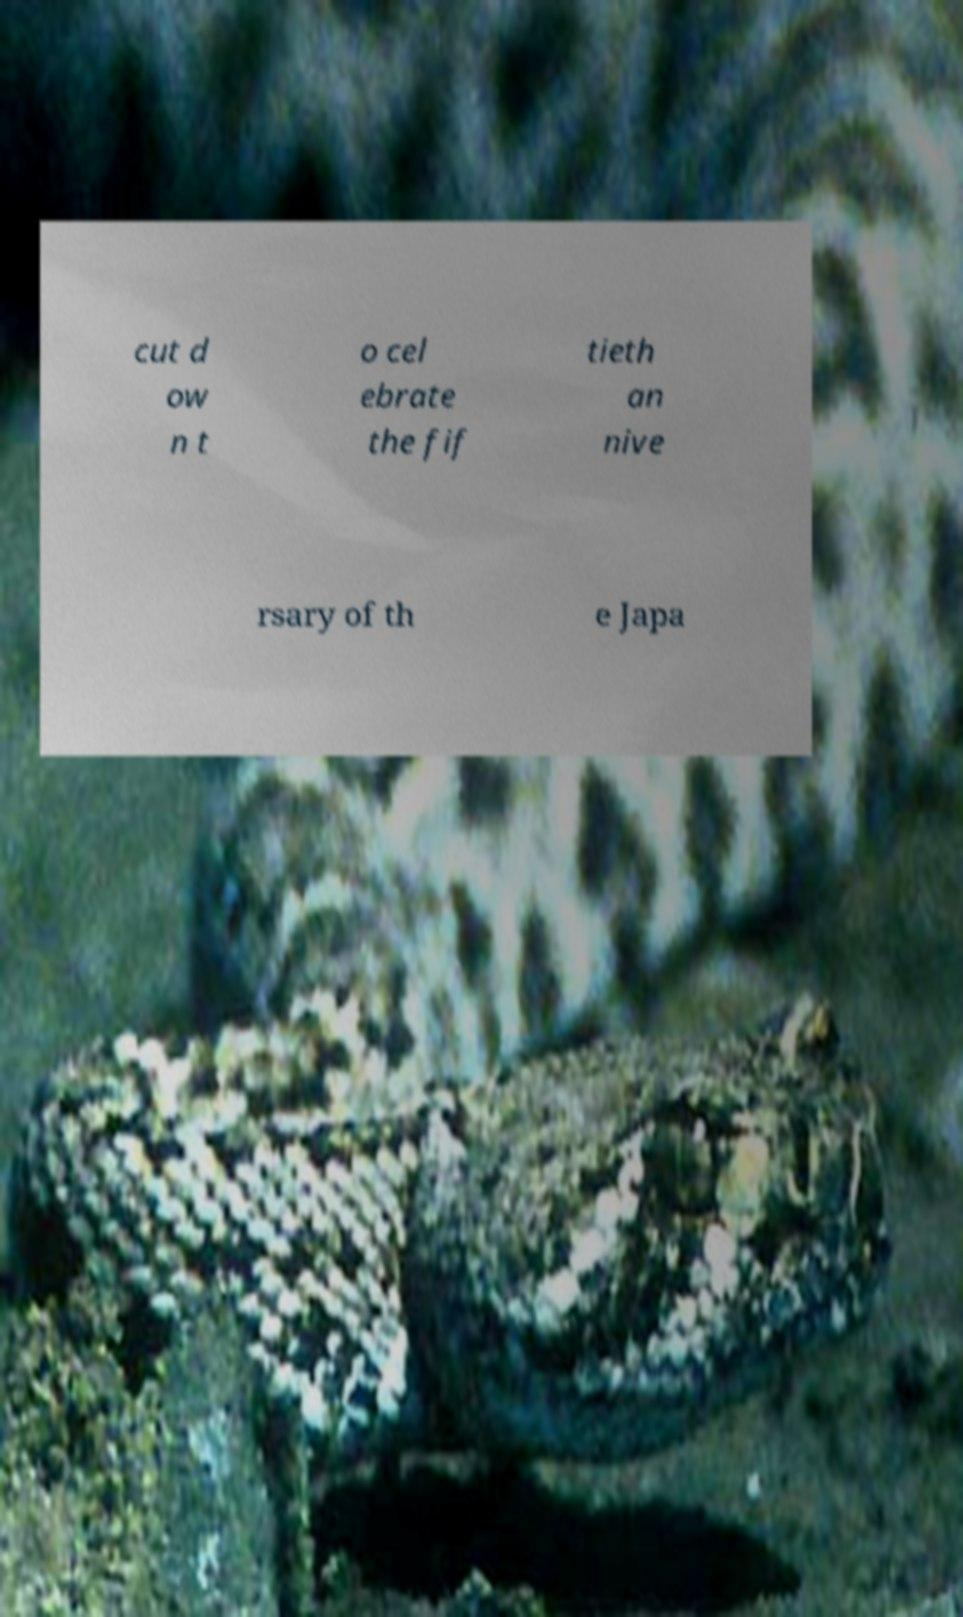Please identify and transcribe the text found in this image. cut d ow n t o cel ebrate the fif tieth an nive rsary of th e Japa 